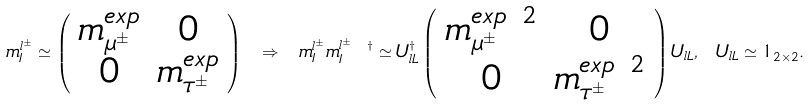<formula> <loc_0><loc_0><loc_500><loc_500>m ^ { l ^ { \pm } } _ { I } \simeq \left ( \begin{array} { c c } m ^ { e x p } _ { \mu ^ { \pm } } & 0 \\ 0 & m ^ { e x p } _ { \tau ^ { \pm } } \end{array} \right ) \ \Rightarrow \ m ^ { l ^ { \pm } } _ { I } m ^ { l ^ { \pm } \ \dagger } _ { I } \simeq U _ { l L } ^ { \dagger } \left ( \begin{array} { c c } m ^ { e x p \ 2 } _ { \mu ^ { \pm } } & 0 \\ 0 & m ^ { e x p \ 2 } _ { \tau ^ { \pm } } \end{array} \right ) U _ { l L } , \ U _ { l L } \simeq { 1 } _ { 2 \times 2 } .</formula> 